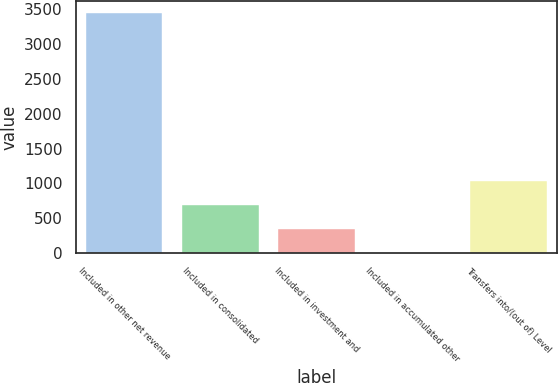Convert chart to OTSL. <chart><loc_0><loc_0><loc_500><loc_500><bar_chart><fcel>Included in other net revenue<fcel>Included in consolidated<fcel>Included in investment and<fcel>Included in accumulated other<fcel>Transfers into/(out of) Level<nl><fcel>3440<fcel>688.55<fcel>344.62<fcel>0.69<fcel>1032.48<nl></chart> 